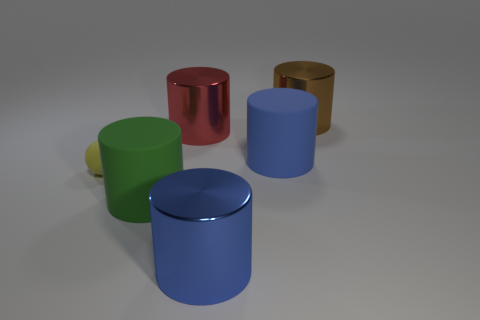Subtract all red cylinders. How many cylinders are left? 4 Subtract all red shiny cylinders. How many cylinders are left? 4 Subtract 1 cylinders. How many cylinders are left? 4 Subtract all yellow cylinders. Subtract all gray cubes. How many cylinders are left? 5 Add 1 large rubber cylinders. How many objects exist? 7 Subtract all cylinders. How many objects are left? 1 Subtract all big yellow cylinders. Subtract all brown objects. How many objects are left? 5 Add 4 green cylinders. How many green cylinders are left? 5 Add 1 blue rubber cylinders. How many blue rubber cylinders exist? 2 Subtract 0 gray blocks. How many objects are left? 6 